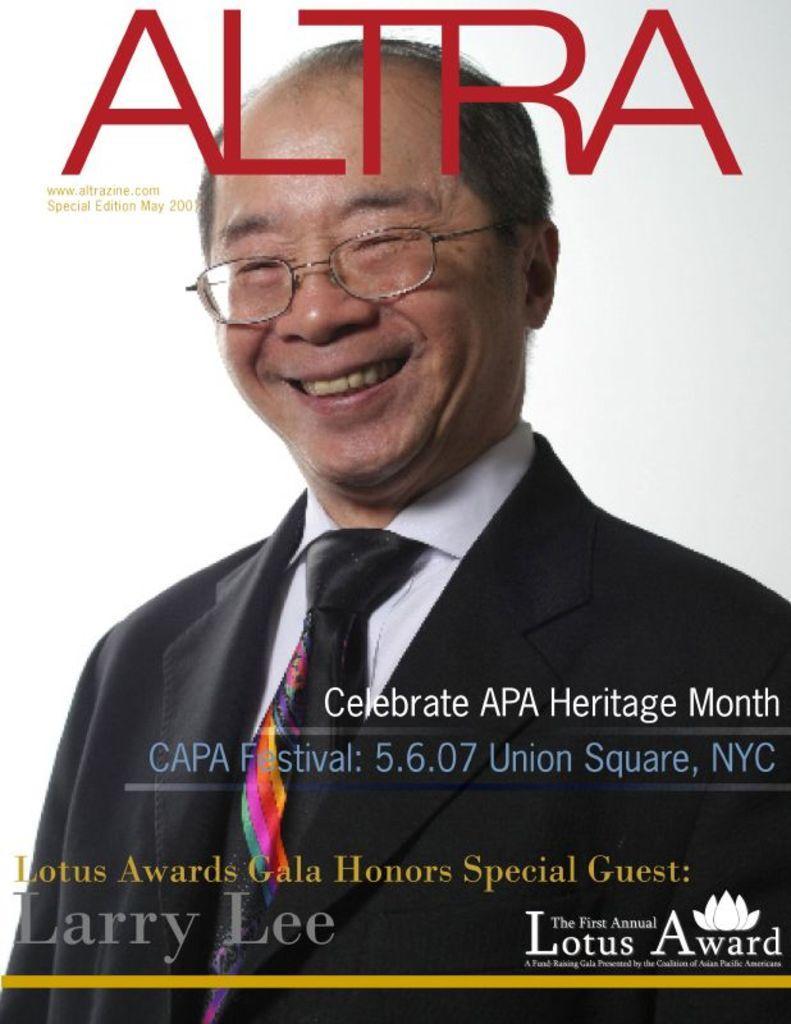Could you give a brief overview of what you see in this image? This picture looks like a cover page and I can see a man and text at the top and the bottom of the picture and I can see white background. 